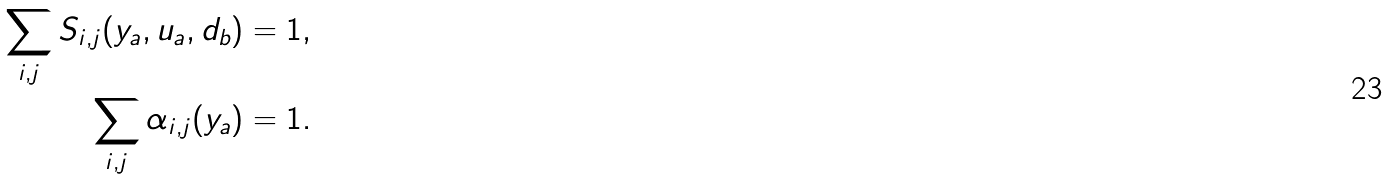Convert formula to latex. <formula><loc_0><loc_0><loc_500><loc_500>\sum _ { i , j } S _ { i , j } ( y _ { a } , u _ { a } , d _ { b } ) & = 1 , \\ \sum _ { i , j } \alpha _ { i , j } ( y _ { a } ) & = 1 .</formula> 